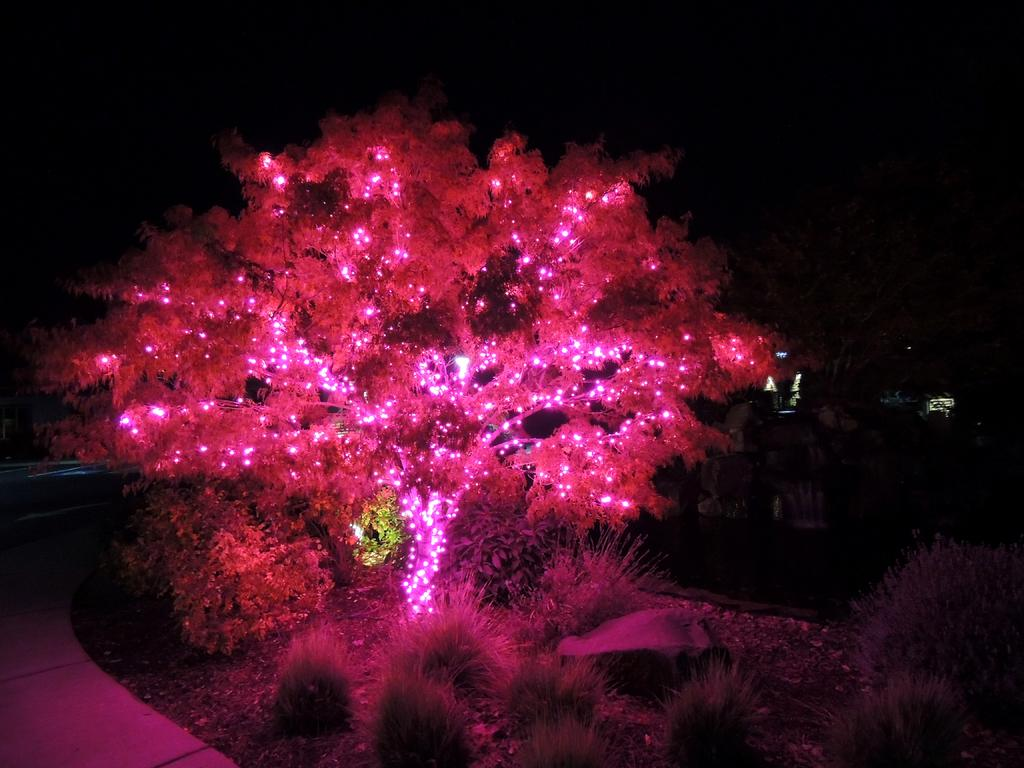What type of vegetation is present in the image? There are grass plants in the image. What other natural element can be seen in the image? There is a tree in the image. How is the tree decorated? The tree is decorated with lights. What colors are the lights on the tree? The lights on the tree are red and pink in color. What can be inferred about the time of day or lighting conditions in the image? The background of the image is dark. What is the rate of heat dissipation from the grass plants in the image? There is no information about the heat dissipation rate of the grass plants in the image, as it is not relevant to the visual content. 